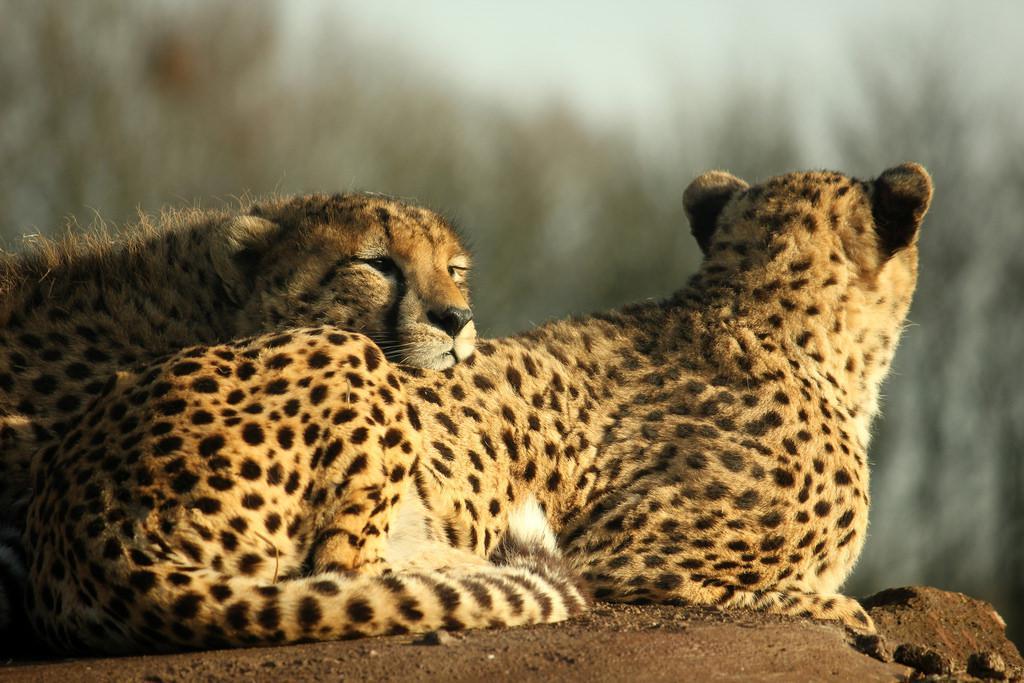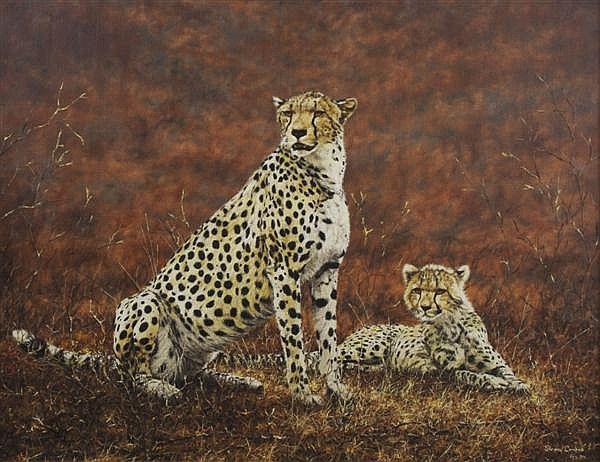The first image is the image on the left, the second image is the image on the right. Examine the images to the left and right. Is the description "Each image contains exactly two cheetahs, and each image includes at least one reclining cheetah." accurate? Answer yes or no. Yes. The first image is the image on the left, the second image is the image on the right. Examine the images to the left and right. Is the description "In one of the images there is a single animal standing in a field." accurate? Answer yes or no. No. 